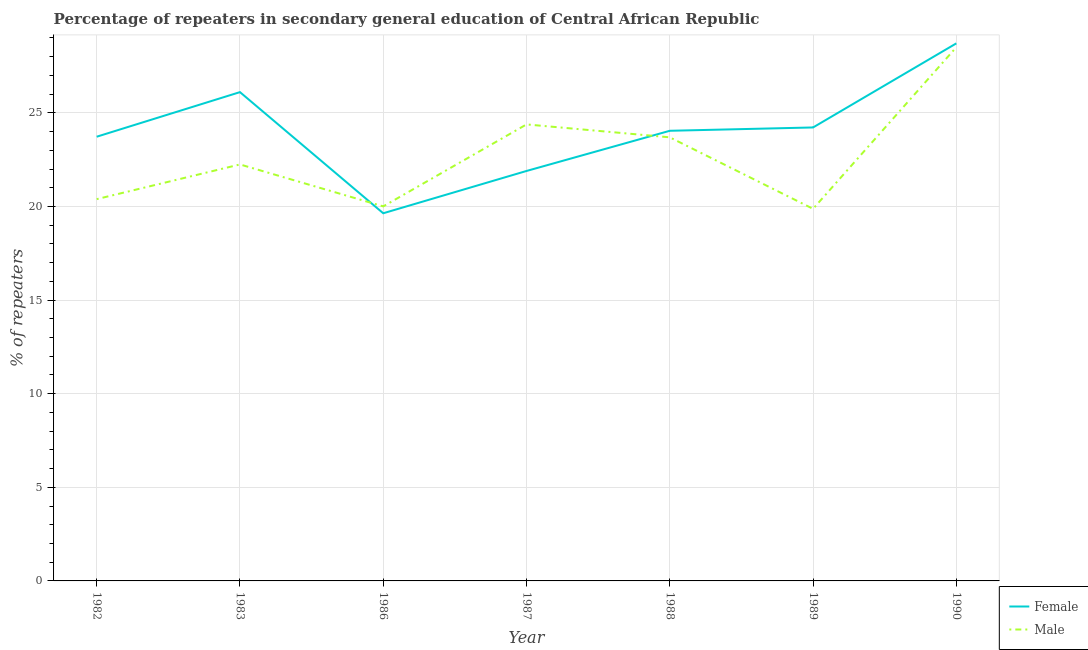How many different coloured lines are there?
Give a very brief answer. 2. Does the line corresponding to percentage of female repeaters intersect with the line corresponding to percentage of male repeaters?
Offer a terse response. Yes. What is the percentage of male repeaters in 1990?
Keep it short and to the point. 28.51. Across all years, what is the maximum percentage of male repeaters?
Give a very brief answer. 28.51. Across all years, what is the minimum percentage of male repeaters?
Offer a terse response. 19.87. In which year was the percentage of male repeaters minimum?
Keep it short and to the point. 1989. What is the total percentage of male repeaters in the graph?
Offer a terse response. 159.1. What is the difference between the percentage of male repeaters in 1983 and that in 1987?
Keep it short and to the point. -2.14. What is the difference between the percentage of female repeaters in 1986 and the percentage of male repeaters in 1983?
Ensure brevity in your answer.  -2.61. What is the average percentage of female repeaters per year?
Give a very brief answer. 24.05. In the year 1986, what is the difference between the percentage of male repeaters and percentage of female repeaters?
Give a very brief answer. 0.37. What is the ratio of the percentage of male repeaters in 1982 to that in 1989?
Your response must be concise. 1.03. What is the difference between the highest and the second highest percentage of male repeaters?
Offer a terse response. 4.12. What is the difference between the highest and the lowest percentage of male repeaters?
Your answer should be very brief. 8.63. In how many years, is the percentage of male repeaters greater than the average percentage of male repeaters taken over all years?
Offer a terse response. 3. Is the sum of the percentage of female repeaters in 1986 and 1989 greater than the maximum percentage of male repeaters across all years?
Your answer should be very brief. Yes. Does the percentage of male repeaters monotonically increase over the years?
Your answer should be very brief. No. Is the percentage of female repeaters strictly greater than the percentage of male repeaters over the years?
Offer a very short reply. No. Does the graph contain any zero values?
Offer a very short reply. No. Does the graph contain grids?
Offer a terse response. Yes. Where does the legend appear in the graph?
Provide a succinct answer. Bottom right. How are the legend labels stacked?
Keep it short and to the point. Vertical. What is the title of the graph?
Your response must be concise. Percentage of repeaters in secondary general education of Central African Republic. What is the label or title of the Y-axis?
Give a very brief answer. % of repeaters. What is the % of repeaters in Female in 1982?
Your response must be concise. 23.73. What is the % of repeaters in Male in 1982?
Your response must be concise. 20.39. What is the % of repeaters of Female in 1983?
Offer a terse response. 26.11. What is the % of repeaters of Male in 1983?
Offer a very short reply. 22.24. What is the % of repeaters of Female in 1986?
Make the answer very short. 19.64. What is the % of repeaters in Male in 1986?
Offer a terse response. 20. What is the % of repeaters in Female in 1987?
Keep it short and to the point. 21.9. What is the % of repeaters in Male in 1987?
Your answer should be very brief. 24.38. What is the % of repeaters of Female in 1988?
Your response must be concise. 24.04. What is the % of repeaters in Male in 1988?
Your answer should be compact. 23.69. What is the % of repeaters of Female in 1989?
Provide a succinct answer. 24.22. What is the % of repeaters in Male in 1989?
Your answer should be very brief. 19.87. What is the % of repeaters of Female in 1990?
Give a very brief answer. 28.71. What is the % of repeaters in Male in 1990?
Your response must be concise. 28.51. Across all years, what is the maximum % of repeaters of Female?
Keep it short and to the point. 28.71. Across all years, what is the maximum % of repeaters of Male?
Make the answer very short. 28.51. Across all years, what is the minimum % of repeaters of Female?
Make the answer very short. 19.64. Across all years, what is the minimum % of repeaters of Male?
Ensure brevity in your answer.  19.87. What is the total % of repeaters of Female in the graph?
Ensure brevity in your answer.  168.34. What is the total % of repeaters of Male in the graph?
Your answer should be very brief. 159.1. What is the difference between the % of repeaters of Female in 1982 and that in 1983?
Your answer should be very brief. -2.38. What is the difference between the % of repeaters in Male in 1982 and that in 1983?
Your answer should be very brief. -1.85. What is the difference between the % of repeaters in Female in 1982 and that in 1986?
Your answer should be compact. 4.09. What is the difference between the % of repeaters of Male in 1982 and that in 1986?
Offer a very short reply. 0.39. What is the difference between the % of repeaters of Female in 1982 and that in 1987?
Your answer should be very brief. 1.83. What is the difference between the % of repeaters of Male in 1982 and that in 1987?
Your response must be concise. -3.99. What is the difference between the % of repeaters of Female in 1982 and that in 1988?
Your response must be concise. -0.32. What is the difference between the % of repeaters in Male in 1982 and that in 1988?
Keep it short and to the point. -3.3. What is the difference between the % of repeaters in Female in 1982 and that in 1989?
Provide a succinct answer. -0.49. What is the difference between the % of repeaters in Male in 1982 and that in 1989?
Your answer should be very brief. 0.52. What is the difference between the % of repeaters in Female in 1982 and that in 1990?
Make the answer very short. -4.99. What is the difference between the % of repeaters of Male in 1982 and that in 1990?
Keep it short and to the point. -8.11. What is the difference between the % of repeaters in Female in 1983 and that in 1986?
Your response must be concise. 6.47. What is the difference between the % of repeaters of Male in 1983 and that in 1986?
Make the answer very short. 2.24. What is the difference between the % of repeaters of Female in 1983 and that in 1987?
Offer a terse response. 4.21. What is the difference between the % of repeaters in Male in 1983 and that in 1987?
Offer a very short reply. -2.14. What is the difference between the % of repeaters in Female in 1983 and that in 1988?
Offer a terse response. 2.06. What is the difference between the % of repeaters of Male in 1983 and that in 1988?
Make the answer very short. -1.45. What is the difference between the % of repeaters of Female in 1983 and that in 1989?
Your answer should be compact. 1.89. What is the difference between the % of repeaters in Male in 1983 and that in 1989?
Your answer should be very brief. 2.37. What is the difference between the % of repeaters of Female in 1983 and that in 1990?
Provide a short and direct response. -2.6. What is the difference between the % of repeaters of Male in 1983 and that in 1990?
Offer a very short reply. -6.26. What is the difference between the % of repeaters of Female in 1986 and that in 1987?
Your answer should be compact. -2.26. What is the difference between the % of repeaters of Male in 1986 and that in 1987?
Offer a terse response. -4.38. What is the difference between the % of repeaters of Female in 1986 and that in 1988?
Provide a short and direct response. -4.41. What is the difference between the % of repeaters of Male in 1986 and that in 1988?
Your response must be concise. -3.69. What is the difference between the % of repeaters in Female in 1986 and that in 1989?
Offer a very short reply. -4.58. What is the difference between the % of repeaters of Male in 1986 and that in 1989?
Your answer should be compact. 0.13. What is the difference between the % of repeaters of Female in 1986 and that in 1990?
Offer a very short reply. -9.07. What is the difference between the % of repeaters of Male in 1986 and that in 1990?
Your answer should be very brief. -8.5. What is the difference between the % of repeaters of Female in 1987 and that in 1988?
Give a very brief answer. -2.15. What is the difference between the % of repeaters of Male in 1987 and that in 1988?
Give a very brief answer. 0.69. What is the difference between the % of repeaters of Female in 1987 and that in 1989?
Ensure brevity in your answer.  -2.32. What is the difference between the % of repeaters of Male in 1987 and that in 1989?
Make the answer very short. 4.51. What is the difference between the % of repeaters in Female in 1987 and that in 1990?
Provide a short and direct response. -6.82. What is the difference between the % of repeaters of Male in 1987 and that in 1990?
Offer a terse response. -4.12. What is the difference between the % of repeaters in Female in 1988 and that in 1989?
Ensure brevity in your answer.  -0.18. What is the difference between the % of repeaters in Male in 1988 and that in 1989?
Your answer should be very brief. 3.82. What is the difference between the % of repeaters in Female in 1988 and that in 1990?
Ensure brevity in your answer.  -4.67. What is the difference between the % of repeaters in Male in 1988 and that in 1990?
Your answer should be very brief. -4.81. What is the difference between the % of repeaters of Female in 1989 and that in 1990?
Keep it short and to the point. -4.49. What is the difference between the % of repeaters of Male in 1989 and that in 1990?
Offer a terse response. -8.63. What is the difference between the % of repeaters of Female in 1982 and the % of repeaters of Male in 1983?
Your response must be concise. 1.48. What is the difference between the % of repeaters in Female in 1982 and the % of repeaters in Male in 1986?
Your answer should be compact. 3.72. What is the difference between the % of repeaters in Female in 1982 and the % of repeaters in Male in 1987?
Your answer should be compact. -0.66. What is the difference between the % of repeaters of Female in 1982 and the % of repeaters of Male in 1988?
Your response must be concise. 0.03. What is the difference between the % of repeaters of Female in 1982 and the % of repeaters of Male in 1989?
Make the answer very short. 3.85. What is the difference between the % of repeaters in Female in 1982 and the % of repeaters in Male in 1990?
Your answer should be compact. -4.78. What is the difference between the % of repeaters of Female in 1983 and the % of repeaters of Male in 1986?
Provide a succinct answer. 6.1. What is the difference between the % of repeaters of Female in 1983 and the % of repeaters of Male in 1987?
Ensure brevity in your answer.  1.72. What is the difference between the % of repeaters of Female in 1983 and the % of repeaters of Male in 1988?
Your answer should be compact. 2.41. What is the difference between the % of repeaters of Female in 1983 and the % of repeaters of Male in 1989?
Ensure brevity in your answer.  6.23. What is the difference between the % of repeaters in Female in 1983 and the % of repeaters in Male in 1990?
Offer a very short reply. -2.4. What is the difference between the % of repeaters in Female in 1986 and the % of repeaters in Male in 1987?
Your answer should be very brief. -4.75. What is the difference between the % of repeaters of Female in 1986 and the % of repeaters of Male in 1988?
Offer a terse response. -4.06. What is the difference between the % of repeaters in Female in 1986 and the % of repeaters in Male in 1989?
Provide a short and direct response. -0.24. What is the difference between the % of repeaters of Female in 1986 and the % of repeaters of Male in 1990?
Your answer should be very brief. -8.87. What is the difference between the % of repeaters of Female in 1987 and the % of repeaters of Male in 1988?
Your answer should be very brief. -1.8. What is the difference between the % of repeaters of Female in 1987 and the % of repeaters of Male in 1989?
Your answer should be very brief. 2.02. What is the difference between the % of repeaters of Female in 1987 and the % of repeaters of Male in 1990?
Make the answer very short. -6.61. What is the difference between the % of repeaters of Female in 1988 and the % of repeaters of Male in 1989?
Your response must be concise. 4.17. What is the difference between the % of repeaters in Female in 1988 and the % of repeaters in Male in 1990?
Ensure brevity in your answer.  -4.46. What is the difference between the % of repeaters of Female in 1989 and the % of repeaters of Male in 1990?
Ensure brevity in your answer.  -4.29. What is the average % of repeaters of Female per year?
Provide a short and direct response. 24.05. What is the average % of repeaters in Male per year?
Your response must be concise. 22.73. In the year 1982, what is the difference between the % of repeaters of Female and % of repeaters of Male?
Offer a terse response. 3.33. In the year 1983, what is the difference between the % of repeaters in Female and % of repeaters in Male?
Your response must be concise. 3.86. In the year 1986, what is the difference between the % of repeaters of Female and % of repeaters of Male?
Make the answer very short. -0.37. In the year 1987, what is the difference between the % of repeaters of Female and % of repeaters of Male?
Ensure brevity in your answer.  -2.49. In the year 1988, what is the difference between the % of repeaters in Female and % of repeaters in Male?
Give a very brief answer. 0.35. In the year 1989, what is the difference between the % of repeaters in Female and % of repeaters in Male?
Provide a short and direct response. 4.35. In the year 1990, what is the difference between the % of repeaters in Female and % of repeaters in Male?
Make the answer very short. 0.21. What is the ratio of the % of repeaters in Female in 1982 to that in 1983?
Offer a terse response. 0.91. What is the ratio of the % of repeaters of Male in 1982 to that in 1983?
Give a very brief answer. 0.92. What is the ratio of the % of repeaters in Female in 1982 to that in 1986?
Make the answer very short. 1.21. What is the ratio of the % of repeaters in Male in 1982 to that in 1986?
Offer a terse response. 1.02. What is the ratio of the % of repeaters in Female in 1982 to that in 1987?
Your response must be concise. 1.08. What is the ratio of the % of repeaters of Male in 1982 to that in 1987?
Make the answer very short. 0.84. What is the ratio of the % of repeaters of Male in 1982 to that in 1988?
Provide a short and direct response. 0.86. What is the ratio of the % of repeaters in Female in 1982 to that in 1989?
Give a very brief answer. 0.98. What is the ratio of the % of repeaters in Male in 1982 to that in 1989?
Make the answer very short. 1.03. What is the ratio of the % of repeaters of Female in 1982 to that in 1990?
Your answer should be compact. 0.83. What is the ratio of the % of repeaters in Male in 1982 to that in 1990?
Ensure brevity in your answer.  0.72. What is the ratio of the % of repeaters of Female in 1983 to that in 1986?
Provide a succinct answer. 1.33. What is the ratio of the % of repeaters of Male in 1983 to that in 1986?
Offer a very short reply. 1.11. What is the ratio of the % of repeaters in Female in 1983 to that in 1987?
Keep it short and to the point. 1.19. What is the ratio of the % of repeaters of Male in 1983 to that in 1987?
Give a very brief answer. 0.91. What is the ratio of the % of repeaters in Female in 1983 to that in 1988?
Provide a short and direct response. 1.09. What is the ratio of the % of repeaters in Male in 1983 to that in 1988?
Give a very brief answer. 0.94. What is the ratio of the % of repeaters of Female in 1983 to that in 1989?
Your response must be concise. 1.08. What is the ratio of the % of repeaters in Male in 1983 to that in 1989?
Make the answer very short. 1.12. What is the ratio of the % of repeaters in Female in 1983 to that in 1990?
Provide a succinct answer. 0.91. What is the ratio of the % of repeaters in Male in 1983 to that in 1990?
Your response must be concise. 0.78. What is the ratio of the % of repeaters in Female in 1986 to that in 1987?
Your answer should be compact. 0.9. What is the ratio of the % of repeaters of Male in 1986 to that in 1987?
Give a very brief answer. 0.82. What is the ratio of the % of repeaters of Female in 1986 to that in 1988?
Your answer should be very brief. 0.82. What is the ratio of the % of repeaters in Male in 1986 to that in 1988?
Your answer should be very brief. 0.84. What is the ratio of the % of repeaters in Female in 1986 to that in 1989?
Make the answer very short. 0.81. What is the ratio of the % of repeaters in Male in 1986 to that in 1989?
Offer a terse response. 1.01. What is the ratio of the % of repeaters of Female in 1986 to that in 1990?
Ensure brevity in your answer.  0.68. What is the ratio of the % of repeaters of Male in 1986 to that in 1990?
Your answer should be compact. 0.7. What is the ratio of the % of repeaters in Female in 1987 to that in 1988?
Keep it short and to the point. 0.91. What is the ratio of the % of repeaters in Male in 1987 to that in 1988?
Provide a succinct answer. 1.03. What is the ratio of the % of repeaters in Female in 1987 to that in 1989?
Provide a succinct answer. 0.9. What is the ratio of the % of repeaters of Male in 1987 to that in 1989?
Provide a short and direct response. 1.23. What is the ratio of the % of repeaters in Female in 1987 to that in 1990?
Your answer should be compact. 0.76. What is the ratio of the % of repeaters in Male in 1987 to that in 1990?
Make the answer very short. 0.86. What is the ratio of the % of repeaters in Female in 1988 to that in 1989?
Ensure brevity in your answer.  0.99. What is the ratio of the % of repeaters of Male in 1988 to that in 1989?
Offer a terse response. 1.19. What is the ratio of the % of repeaters in Female in 1988 to that in 1990?
Keep it short and to the point. 0.84. What is the ratio of the % of repeaters of Male in 1988 to that in 1990?
Ensure brevity in your answer.  0.83. What is the ratio of the % of repeaters of Female in 1989 to that in 1990?
Ensure brevity in your answer.  0.84. What is the ratio of the % of repeaters in Male in 1989 to that in 1990?
Provide a succinct answer. 0.7. What is the difference between the highest and the second highest % of repeaters in Female?
Make the answer very short. 2.6. What is the difference between the highest and the second highest % of repeaters of Male?
Your answer should be very brief. 4.12. What is the difference between the highest and the lowest % of repeaters of Female?
Your response must be concise. 9.07. What is the difference between the highest and the lowest % of repeaters in Male?
Give a very brief answer. 8.63. 